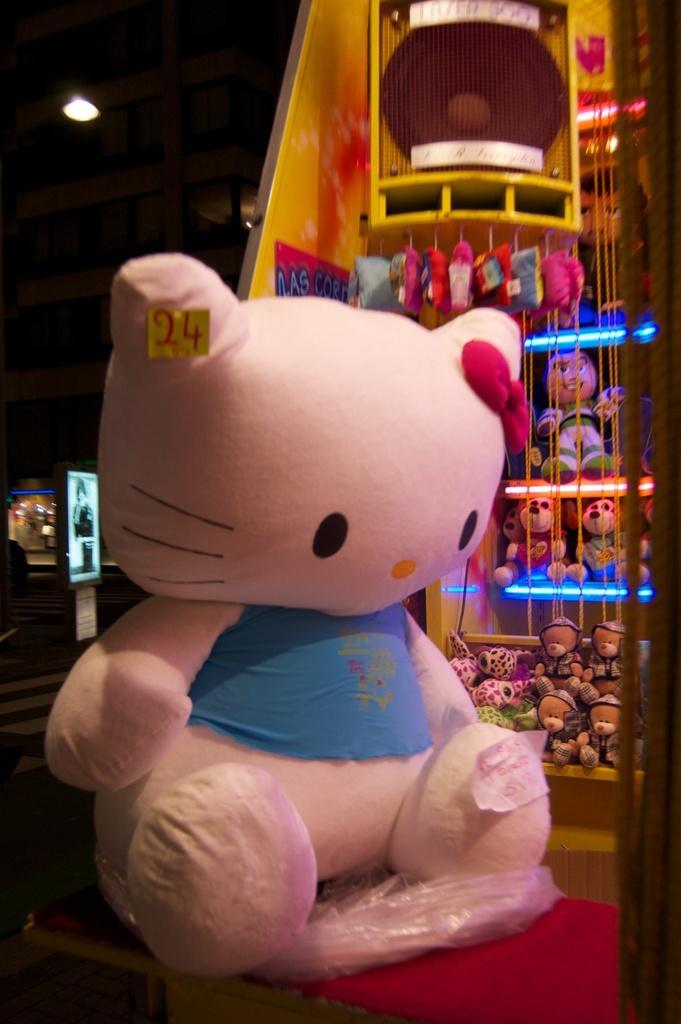Could you give a brief overview of what you see in this image? In the picture I can see soft toys among them the toy in the front is pink in color. In the background I can see lights and some other objects. The background of the image is dark. 